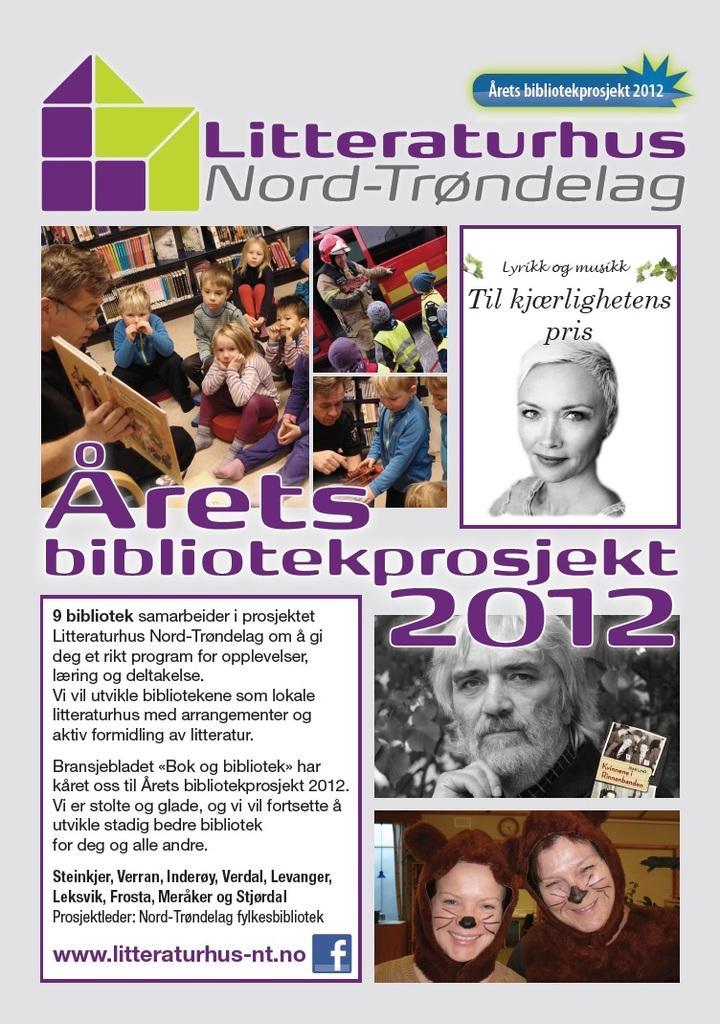Could you give a brief overview of what you see in this image? In this image we can see a poster. On poster we can see few people and some text. 